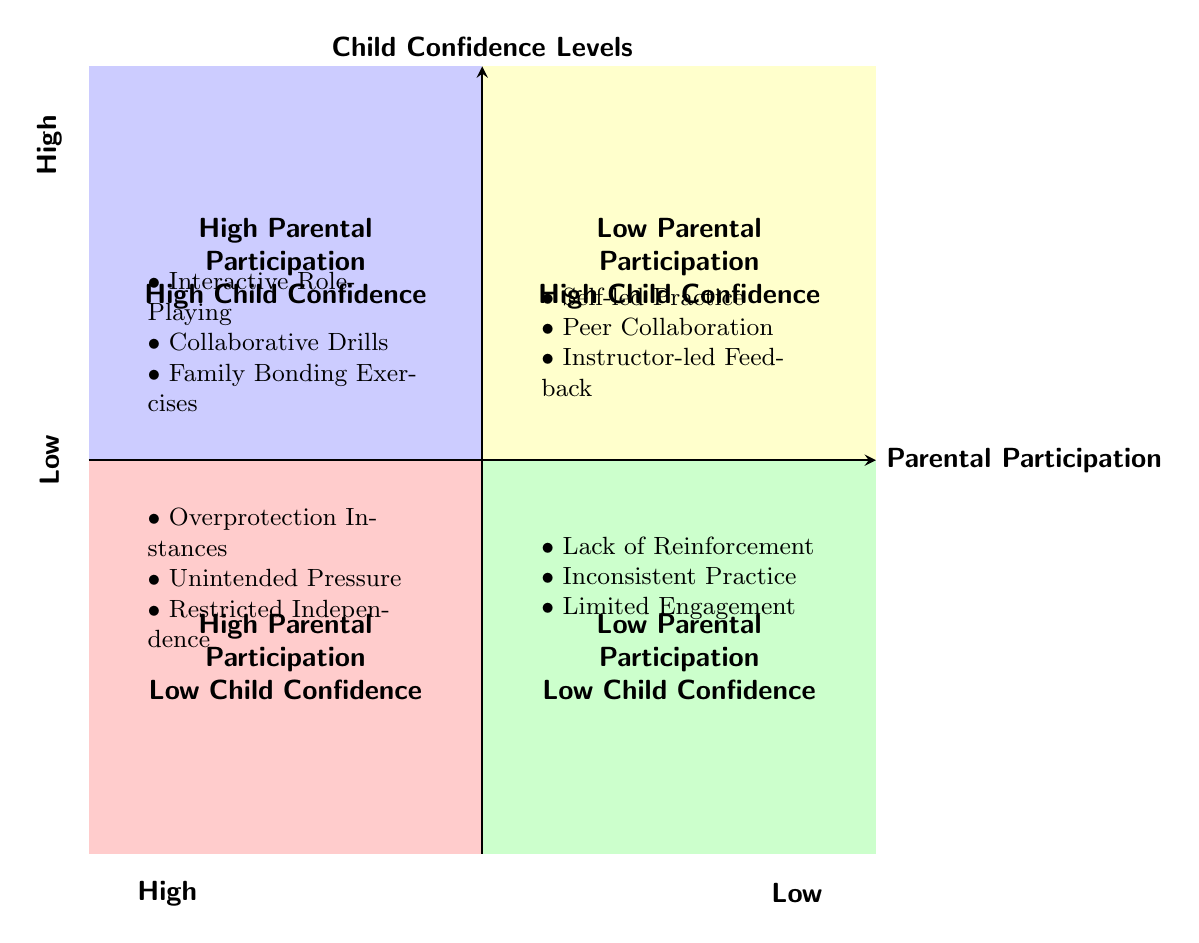What activities lead to high child confidence levels with high parental participation? In the quadrant where both parental participation and child confidence levels are high, the activities listed are "Interactive Role-Playing," "Collaborative Drills," and "Family Bonding Exercises."
Answer: Interactive Role-Playing, Collaborative Drills, Family Bonding Exercises What are the factors resulting in low child confidence levels combined with high parental participation? In the quadrant that correlates high parental participation with low child confidence levels, the listed factors are "Overprotection Instances," "Unintended Pressure," and "Restricted Independence."
Answer: Overprotection Instances, Unintended Pressure, Restricted Independence How many factors contribute to high child confidence levels with low parental participation? In the quadrant where parental participation is low and child confidence levels are high, there are three factors: "Self-led Practice," "Peer Collaboration," and "Instructor-led Feedback." Counting these gives a total of three factors.
Answer: 3 What correlation exists between low parental participation and low child confidence levels? The quadrant showing low parental participation and low child confidence lists the factors "Lack of Reinforcement," "Inconsistent Practice," and "Limited Engagement." These indicators suggest that when parental involvement is low, child confidence tends to be low as well.
Answer: Lack of Reinforcement, Inconsistent Practice, Limited Engagement In which quadrant would you find "Instructor-led Feedback"? "Instructor-led Feedback" is mentioned in the quadrant labeled as low parental participation and high child confidence levels, indicating its placement according to these metrics.
Answer: Low Parental Participation, High Child Confidence How does high parental participation affect child confidence levels compared to low participation? Based on the quadrants, high parental participation appears to yield varying confidence levels among children, with both high activities associated and low confidence due to negative factors, while low parental participation provides consistent high confidence through self-led activities. This sets up a contrast in outcomes based on parental involvement.
Answer: High and Low Outcomes 